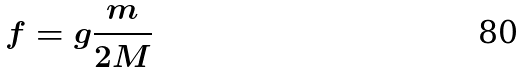<formula> <loc_0><loc_0><loc_500><loc_500>f = g \frac { m } { 2 M }</formula> 